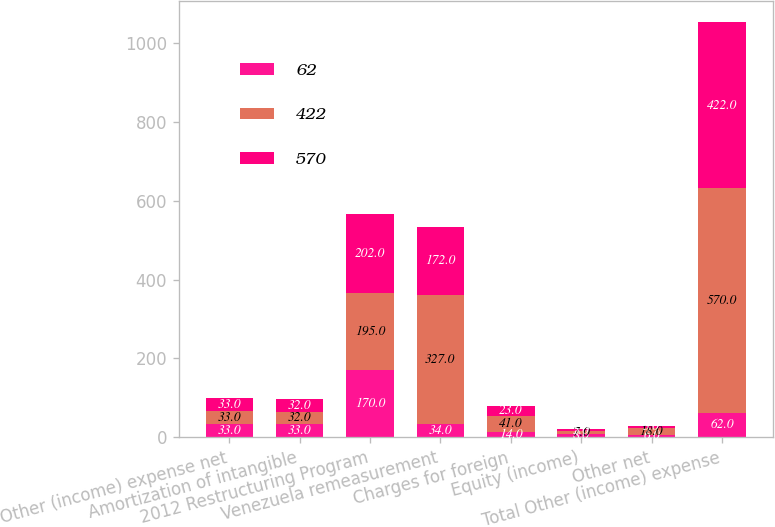Convert chart to OTSL. <chart><loc_0><loc_0><loc_500><loc_500><stacked_bar_chart><ecel><fcel>Other (income) expense net<fcel>Amortization of intangible<fcel>2012 Restructuring Program<fcel>Venezuela remeasurement<fcel>Charges for foreign<fcel>Equity (income)<fcel>Other net<fcel>Total Other (income) expense<nl><fcel>62<fcel>33<fcel>33<fcel>170<fcel>34<fcel>14<fcel>8<fcel>6<fcel>62<nl><fcel>422<fcel>33<fcel>32<fcel>195<fcel>327<fcel>41<fcel>7<fcel>18<fcel>570<nl><fcel>570<fcel>33<fcel>32<fcel>202<fcel>172<fcel>23<fcel>5<fcel>5<fcel>422<nl></chart> 